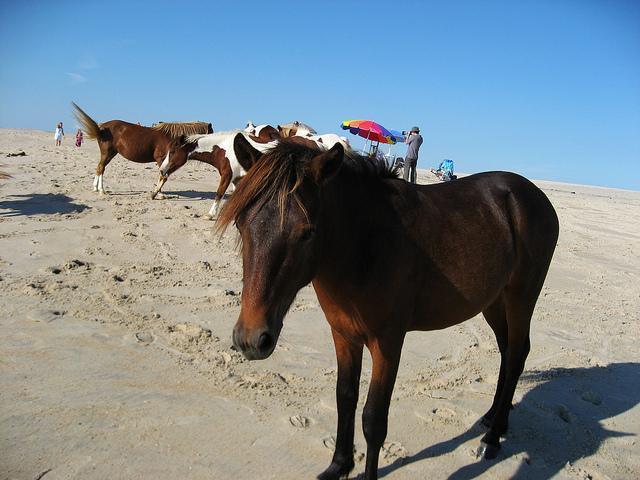How many horses are in the picture?
Give a very brief answer. 3. How many clock faces are in the shade?
Give a very brief answer. 0. 